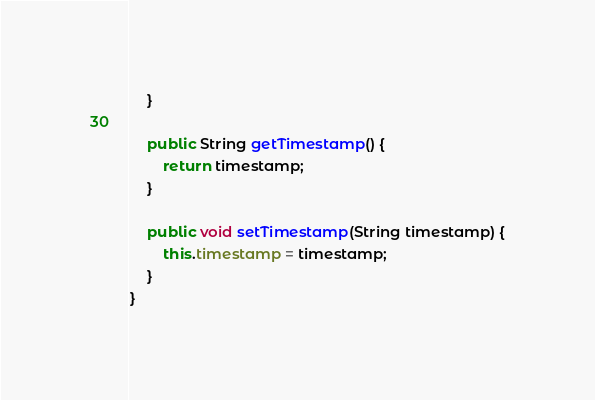Convert code to text. <code><loc_0><loc_0><loc_500><loc_500><_Java_>    }

    public String getTimestamp() {
        return timestamp;
    }

    public void setTimestamp(String timestamp) {
        this.timestamp = timestamp;
    }
}
</code> 